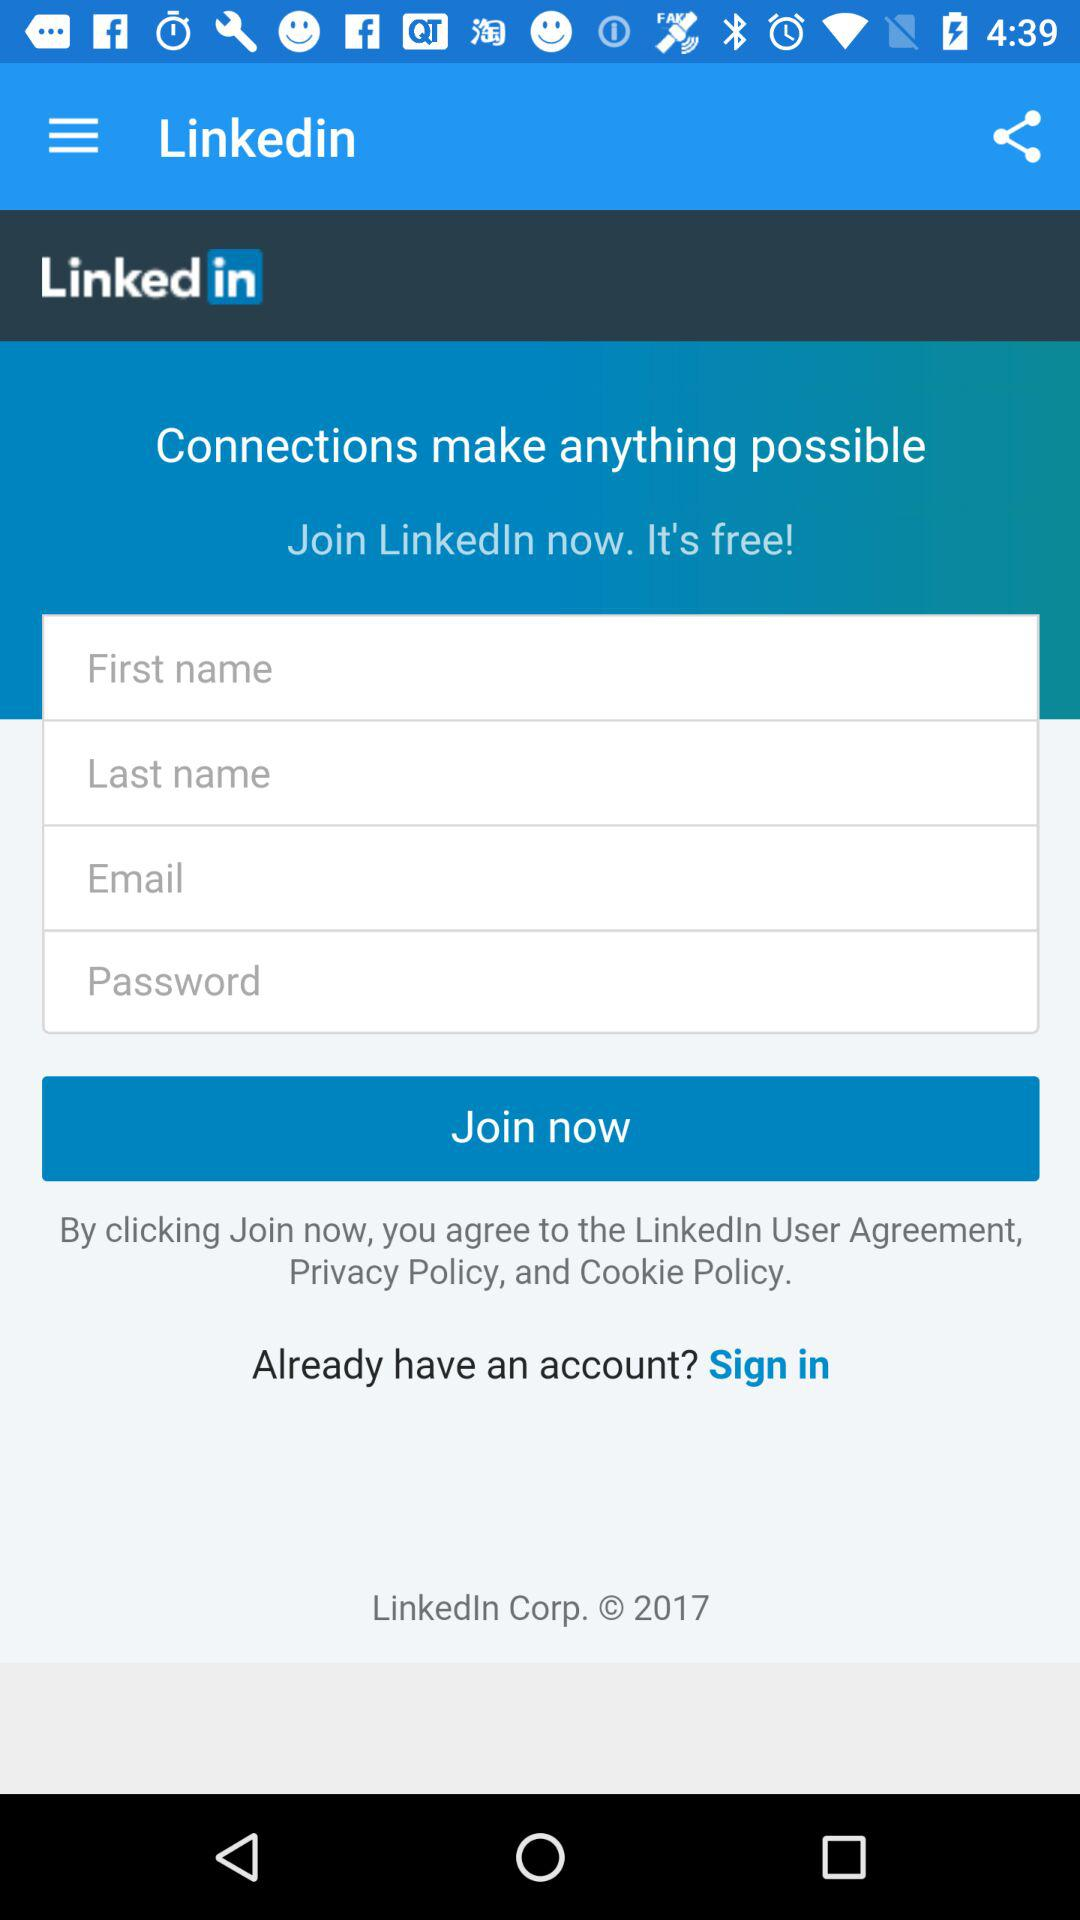What is the year of copyright for the application? The year of copyright for the application is 2017. 